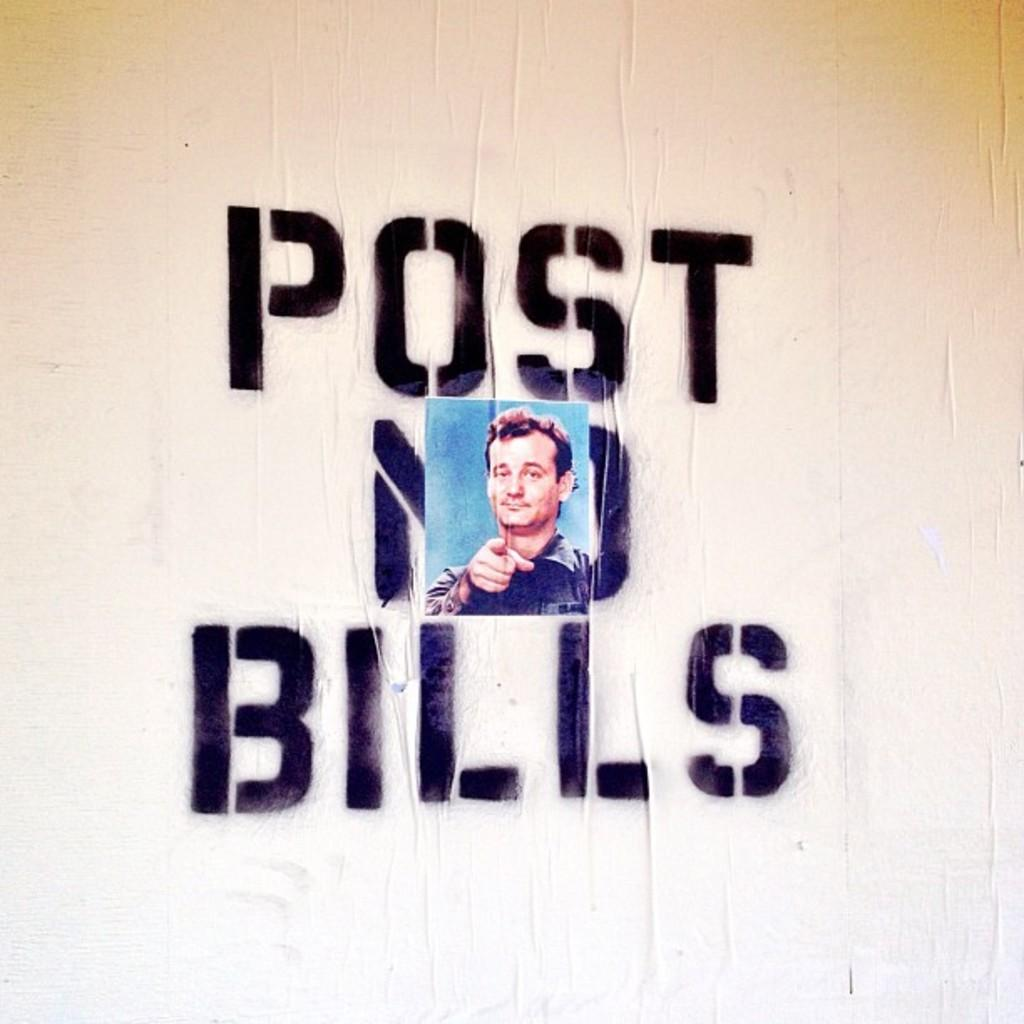What is present on the wall in the image? There is text and a photograph of a man on the wall. Can you describe the photograph on the wall? The photograph on the wall is of a man wearing a black shirt. How does the beginner learn to open the lock in the image? There is no lock present in the image, and therefore no learning process related to it. 